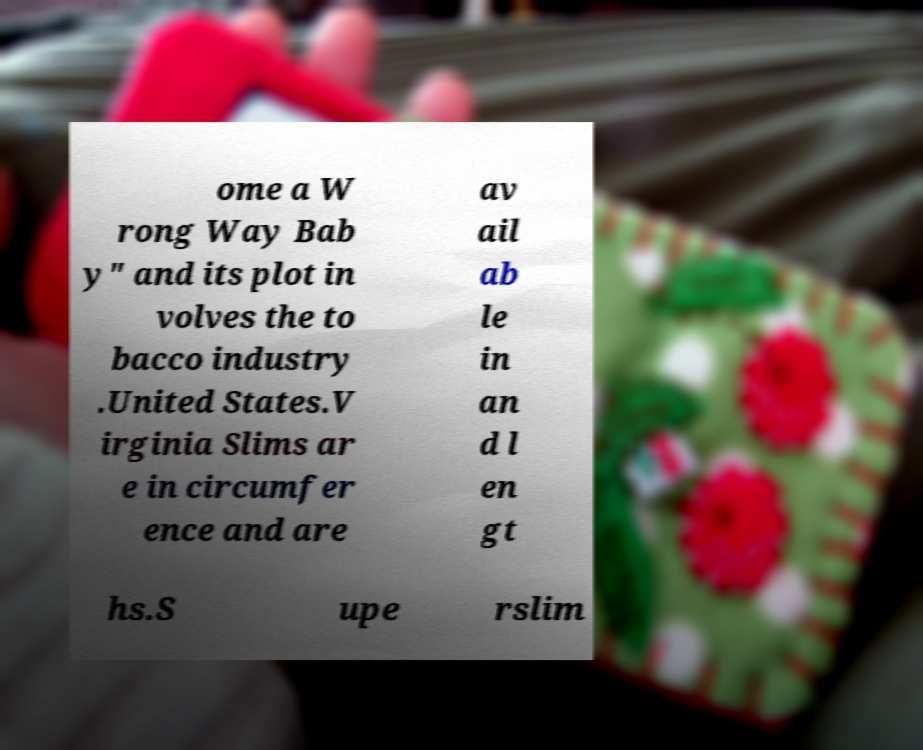Please read and relay the text visible in this image. What does it say? ome a W rong Way Bab y" and its plot in volves the to bacco industry .United States.V irginia Slims ar e in circumfer ence and are av ail ab le in an d l en gt hs.S upe rslim 